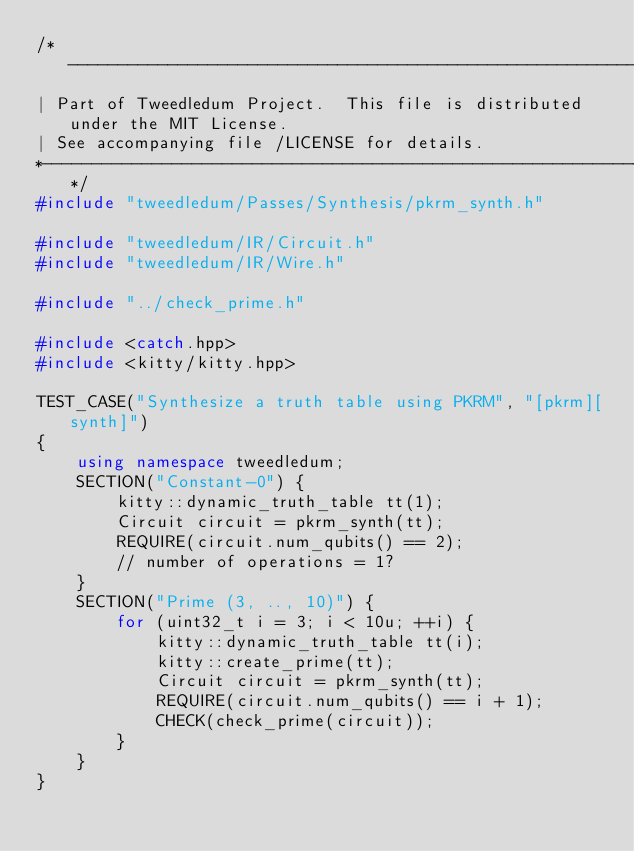Convert code to text. <code><loc_0><loc_0><loc_500><loc_500><_C++_>/*------------------------------------------------------------------------------
| Part of Tweedledum Project.  This file is distributed under the MIT License.
| See accompanying file /LICENSE for details.
*-----------------------------------------------------------------------------*/
#include "tweedledum/Passes/Synthesis/pkrm_synth.h"

#include "tweedledum/IR/Circuit.h"
#include "tweedledum/IR/Wire.h"

#include "../check_prime.h"

#include <catch.hpp>
#include <kitty/kitty.hpp>

TEST_CASE("Synthesize a truth table using PKRM", "[pkrm][synth]")
{
    using namespace tweedledum;
    SECTION("Constant-0") {
        kitty::dynamic_truth_table tt(1);
        Circuit circuit = pkrm_synth(tt);
        REQUIRE(circuit.num_qubits() == 2);
        // number of operations = 1?
    }
    SECTION("Prime (3, .., 10)") {
        for (uint32_t i = 3; i < 10u; ++i) {
            kitty::dynamic_truth_table tt(i);
            kitty::create_prime(tt);
            Circuit circuit = pkrm_synth(tt);
            REQUIRE(circuit.num_qubits() == i + 1);
            CHECK(check_prime(circuit));
        }
    }
}</code> 